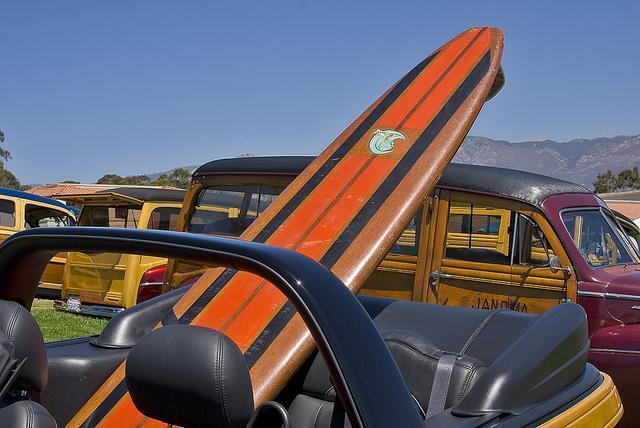How many cars are in the photo?
Give a very brief answer. 4. How many surfboards are there?
Give a very brief answer. 1. How many people in the picture?
Give a very brief answer. 0. 